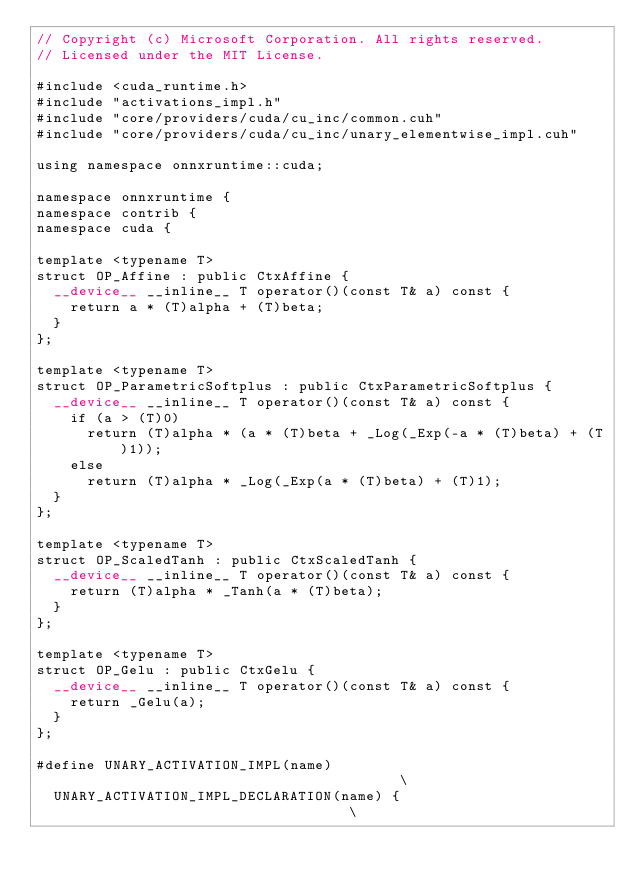<code> <loc_0><loc_0><loc_500><loc_500><_Cuda_>// Copyright (c) Microsoft Corporation. All rights reserved.
// Licensed under the MIT License.

#include <cuda_runtime.h>
#include "activations_impl.h"
#include "core/providers/cuda/cu_inc/common.cuh"
#include "core/providers/cuda/cu_inc/unary_elementwise_impl.cuh"

using namespace onnxruntime::cuda;

namespace onnxruntime {
namespace contrib {
namespace cuda {

template <typename T>
struct OP_Affine : public CtxAffine {
  __device__ __inline__ T operator()(const T& a) const {
    return a * (T)alpha + (T)beta;
  }
};

template <typename T>
struct OP_ParametricSoftplus : public CtxParametricSoftplus {
  __device__ __inline__ T operator()(const T& a) const {
    if (a > (T)0)
      return (T)alpha * (a * (T)beta + _Log(_Exp(-a * (T)beta) + (T)1));
    else
      return (T)alpha * _Log(_Exp(a * (T)beta) + (T)1);
  }
};

template <typename T>
struct OP_ScaledTanh : public CtxScaledTanh {
  __device__ __inline__ T operator()(const T& a) const {
    return (T)alpha * _Tanh(a * (T)beta);
  }
};

template <typename T>
struct OP_Gelu : public CtxGelu {
  __device__ __inline__ T operator()(const T& a) const {
    return _Gelu(a);
  }
};

#define UNARY_ACTIVATION_IMPL(name)                                        \
  UNARY_ACTIVATION_IMPL_DECLARATION(name) {                                \</code> 